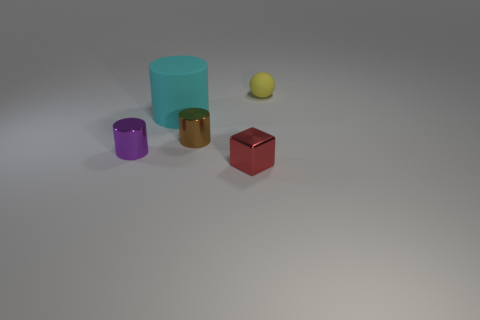What number of small things are both behind the purple cylinder and left of the tiny red metal thing?
Provide a succinct answer. 1. What material is the small thing that is to the right of the red metallic thing?
Offer a terse response. Rubber. What is the size of the yellow ball that is the same material as the large cyan cylinder?
Your answer should be very brief. Small. There is a red object; are there any big things in front of it?
Give a very brief answer. No. There is a purple object that is the same shape as the cyan rubber object; what size is it?
Make the answer very short. Small. There is a matte cylinder; is it the same color as the tiny thing that is on the right side of the small red metallic block?
Your answer should be very brief. No. Is the color of the small metallic block the same as the large cylinder?
Give a very brief answer. No. Are there fewer yellow rubber spheres than large gray shiny blocks?
Provide a succinct answer. No. What number of other things are there of the same color as the matte cylinder?
Offer a terse response. 0. What number of yellow rubber things are there?
Your answer should be compact. 1. 